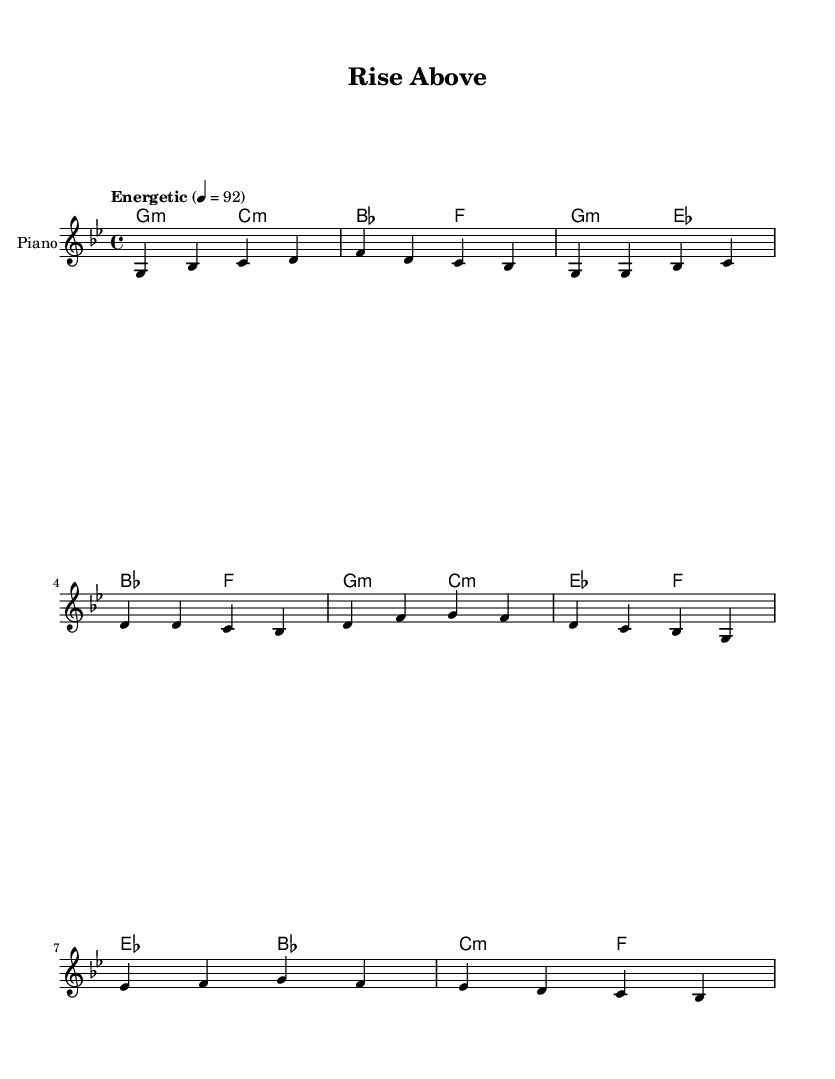What is the key signature of this music? The key signature is G minor, which contains two flats (B flat and E flat). The presence of two flats at the beginning of the sheet music indicates its key signature.
Answer: G minor What is the time signature of this music? The time signature is 4/4, as indicated by the fraction present at the beginning of the sheet music, which denotes four beats in a measure with each beat represented by a quarter note.
Answer: 4/4 What is the tempo marking for this piece? The tempo marking is "Energetic" with a metronome marking of 92 beats per minute, which shows how fast the music should be played, indicated by the tempo notation found at the start of the score.
Answer: Energetic, 92 How many measures are in the provided segments? There are a total of 8 measures present in the segments provided, which can be counted from the notations given in the melody and harmonies sections.
Answer: 8 What type of chords are primarily used in this piece? The primary chords used are minor chords, as reflected by the notation "m" next to several chord symbols in the harmonies section, showing that the piece focuses on a minor tonality.
Answer: Minor Which section of the music does the melody begin with? The melody begins with an intro section, as identified at the beginning of the provided melody line where the music starts before delving into the verses and other parts.
Answer: Intro 